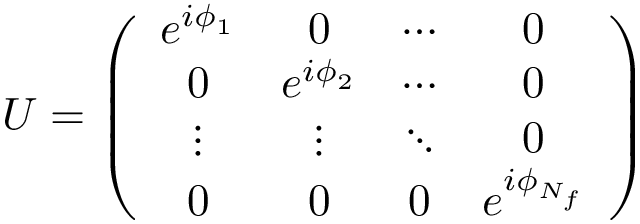<formula> <loc_0><loc_0><loc_500><loc_500>U = \left ( \begin{array} { c c c c } { { e ^ { i \phi _ { 1 } } } } & { 0 } & { \cdots } & { 0 } \\ { 0 } & { { e ^ { i \phi _ { 2 } } } } & { \cdots } & { 0 } \\ { \vdots } & { \vdots } & { \ddots } & { 0 } \\ { 0 } & { 0 } & { 0 } & { { e ^ { i \phi _ { N _ { f } } } } } \end{array} \right )</formula> 